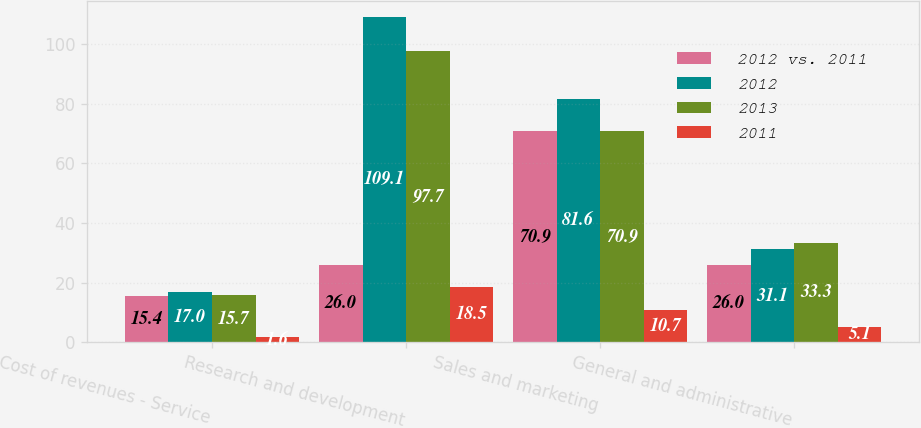Convert chart to OTSL. <chart><loc_0><loc_0><loc_500><loc_500><stacked_bar_chart><ecel><fcel>Cost of revenues - Service<fcel>Research and development<fcel>Sales and marketing<fcel>General and administrative<nl><fcel>2012 vs. 2011<fcel>15.4<fcel>26<fcel>70.9<fcel>26<nl><fcel>2012<fcel>17<fcel>109.1<fcel>81.6<fcel>31.1<nl><fcel>2013<fcel>15.7<fcel>97.7<fcel>70.9<fcel>33.3<nl><fcel>2011<fcel>1.6<fcel>18.5<fcel>10.7<fcel>5.1<nl></chart> 